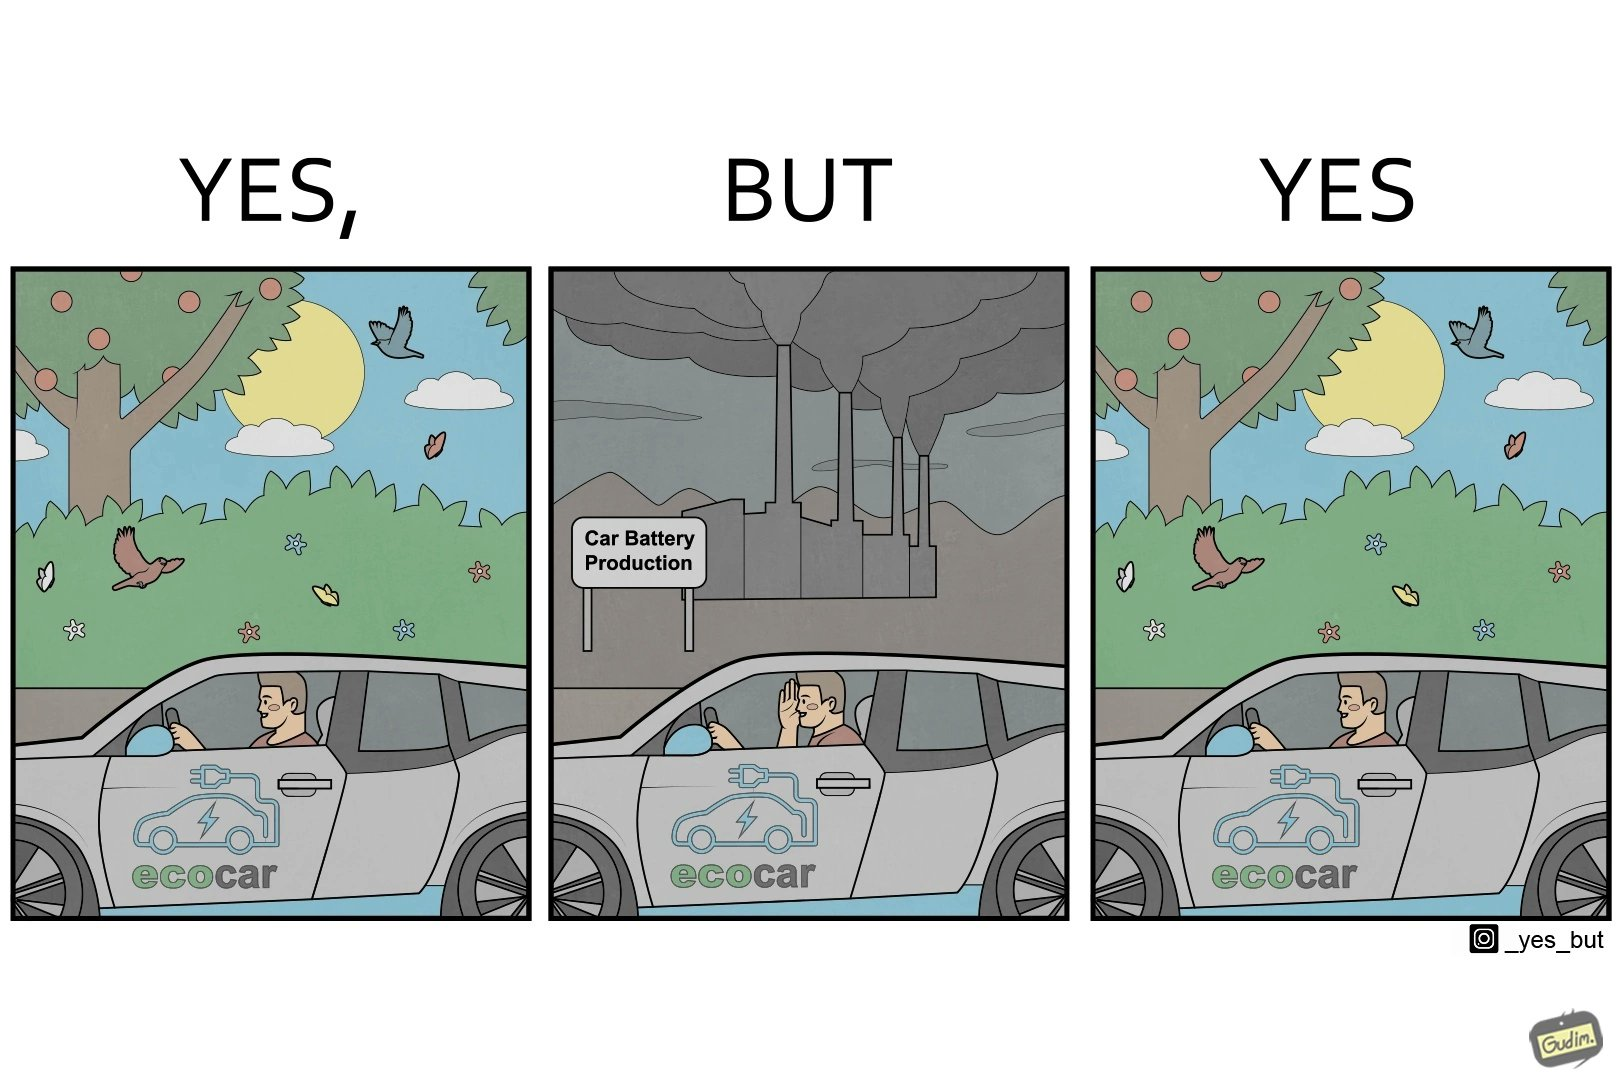Is there satirical content in this image? Yes, this image is satirical. 